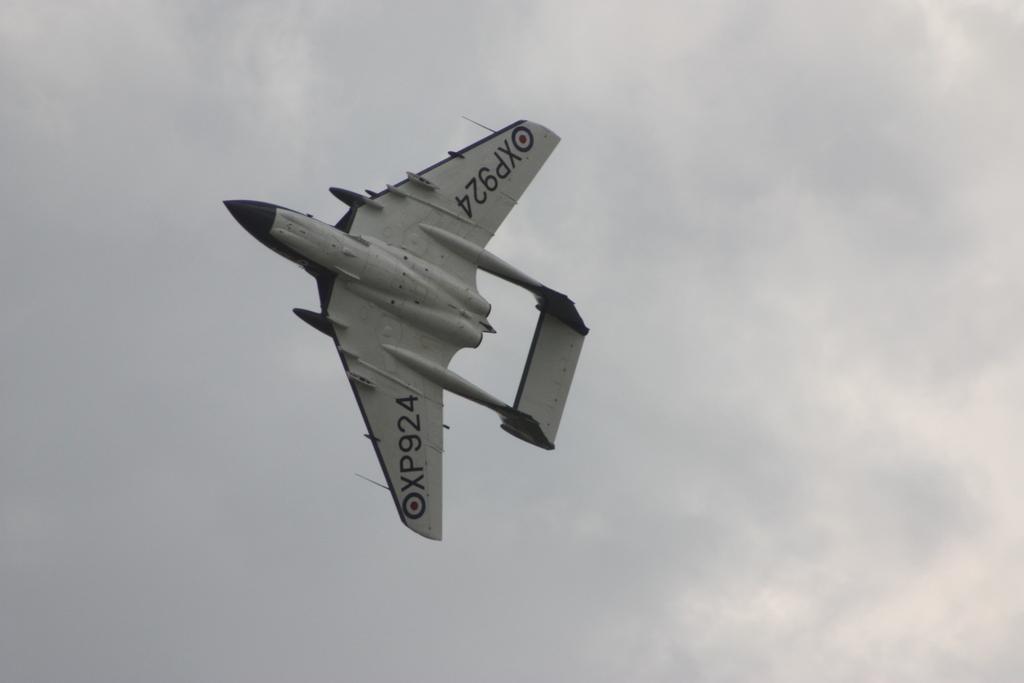What is the plane number?
Your response must be concise. Xp924. 